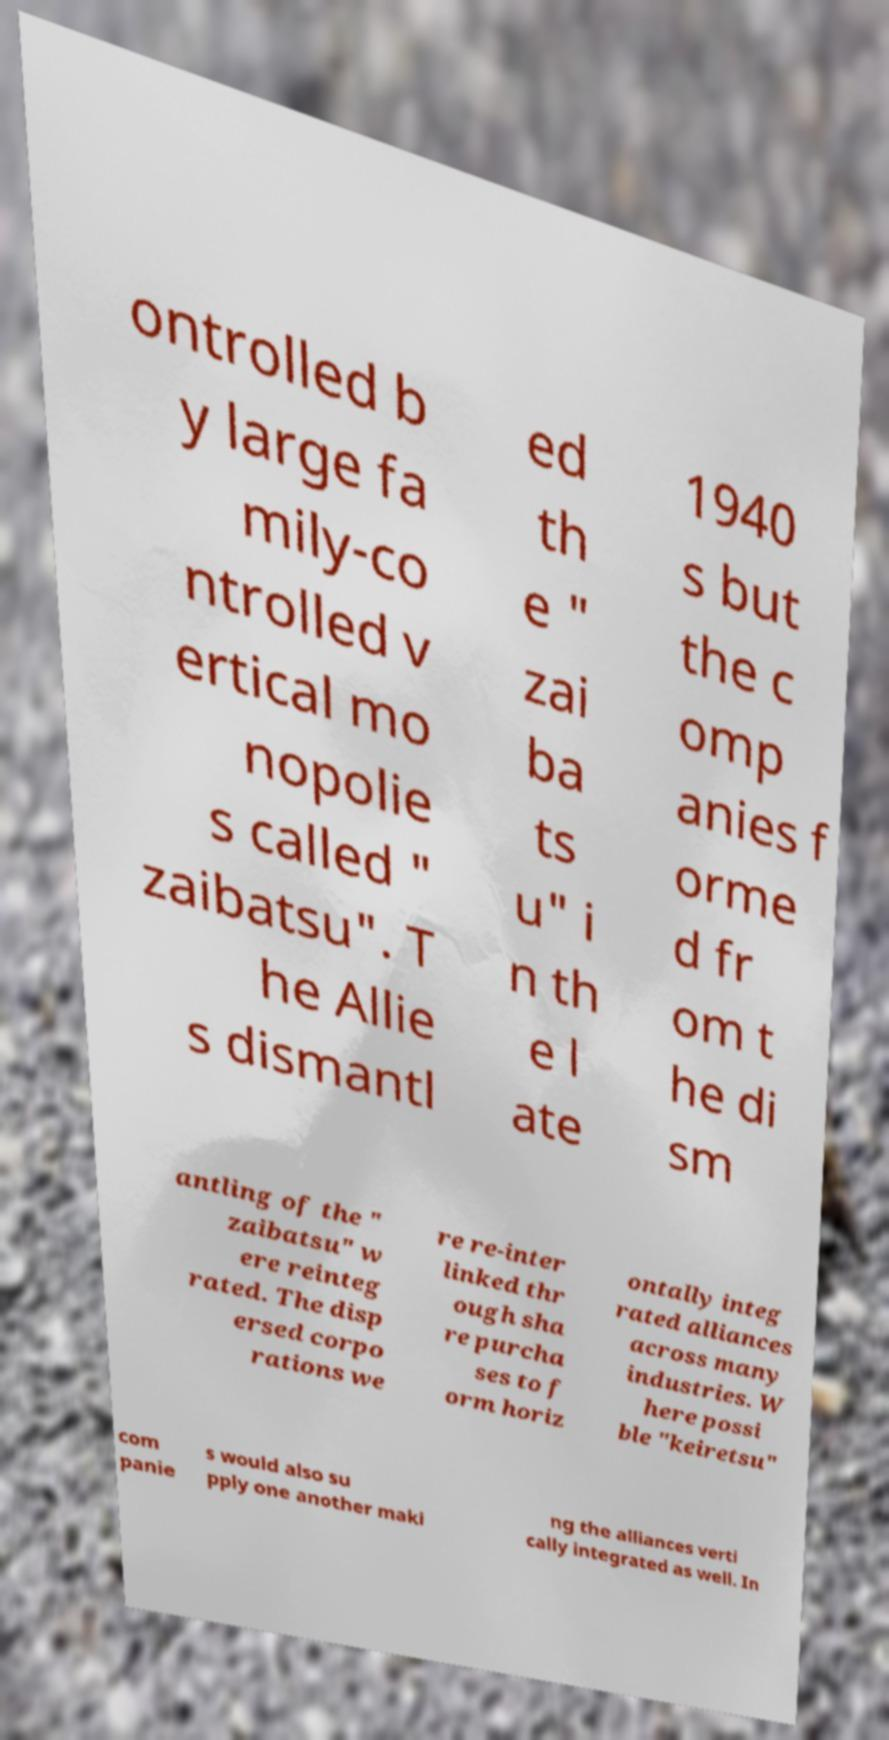Could you extract and type out the text from this image? ontrolled b y large fa mily-co ntrolled v ertical mo nopolie s called " zaibatsu". T he Allie s dismantl ed th e " zai ba ts u" i n th e l ate 1940 s but the c omp anies f orme d fr om t he di sm antling of the " zaibatsu" w ere reinteg rated. The disp ersed corpo rations we re re-inter linked thr ough sha re purcha ses to f orm horiz ontally integ rated alliances across many industries. W here possi ble "keiretsu" com panie s would also su pply one another maki ng the alliances verti cally integrated as well. In 